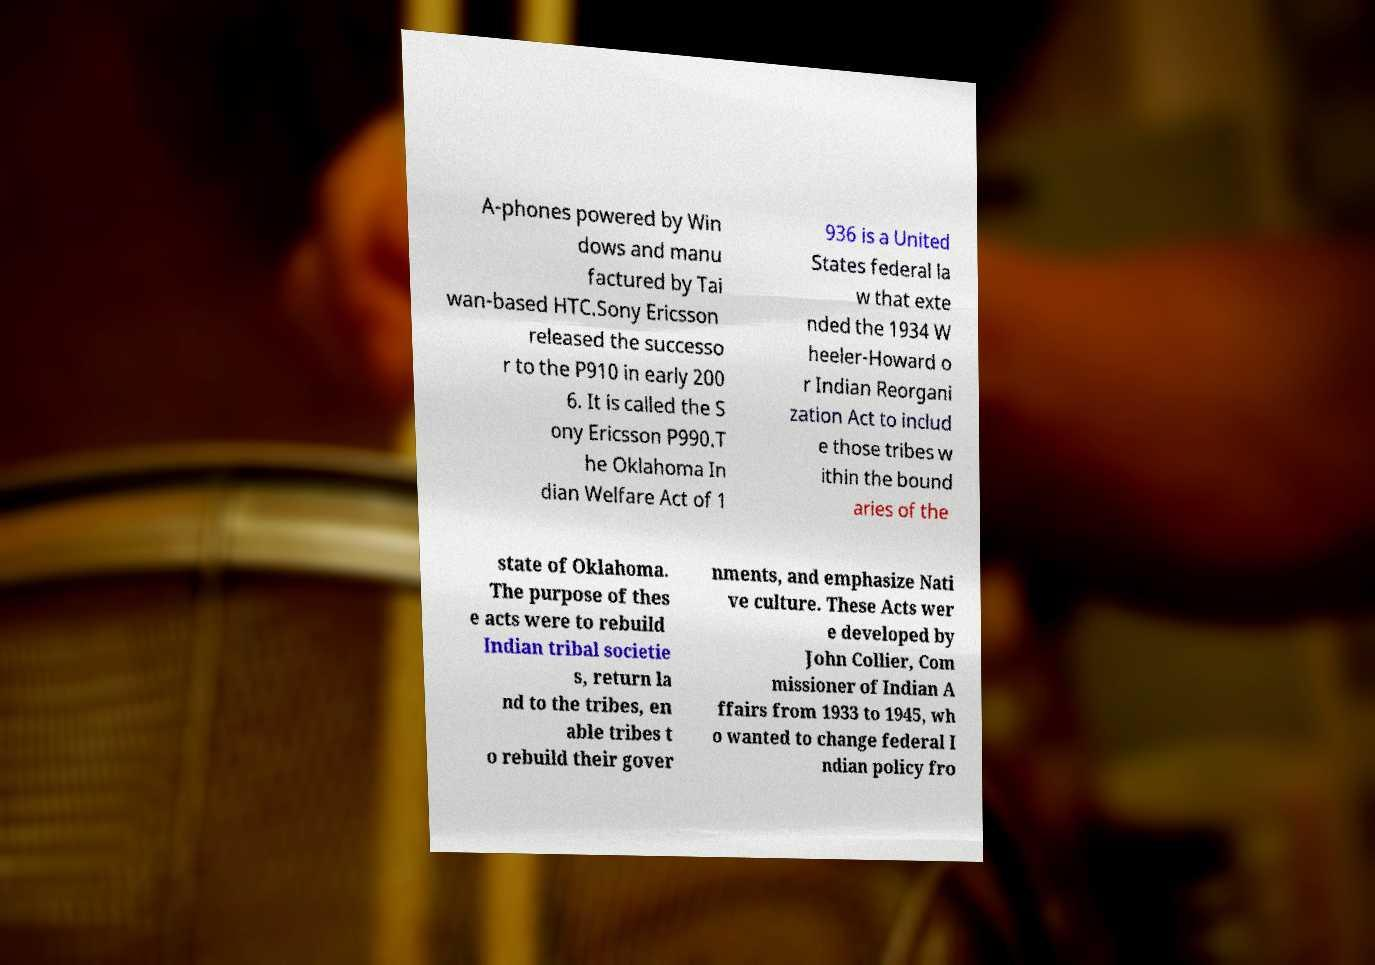I need the written content from this picture converted into text. Can you do that? A-phones powered by Win dows and manu factured by Tai wan-based HTC.Sony Ericsson released the successo r to the P910 in early 200 6. It is called the S ony Ericsson P990.T he Oklahoma In dian Welfare Act of 1 936 is a United States federal la w that exte nded the 1934 W heeler-Howard o r Indian Reorgani zation Act to includ e those tribes w ithin the bound aries of the state of Oklahoma. The purpose of thes e acts were to rebuild Indian tribal societie s, return la nd to the tribes, en able tribes t o rebuild their gover nments, and emphasize Nati ve culture. These Acts wer e developed by John Collier, Com missioner of Indian A ffairs from 1933 to 1945, wh o wanted to change federal I ndian policy fro 